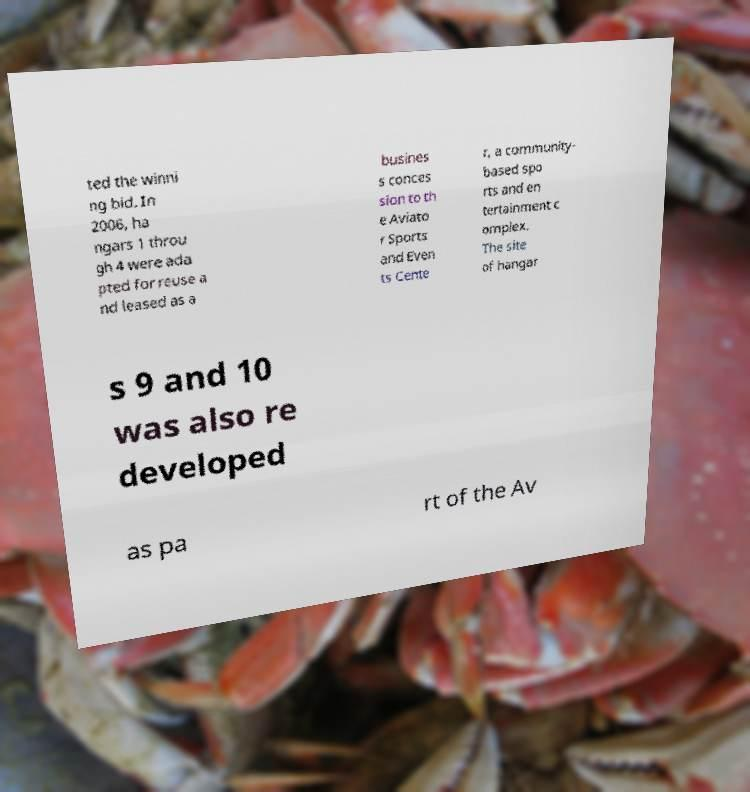Please identify and transcribe the text found in this image. ted the winni ng bid. In 2006, ha ngars 1 throu gh 4 were ada pted for reuse a nd leased as a busines s conces sion to th e Aviato r Sports and Even ts Cente r, a community- based spo rts and en tertainment c omplex. The site of hangar s 9 and 10 was also re developed as pa rt of the Av 